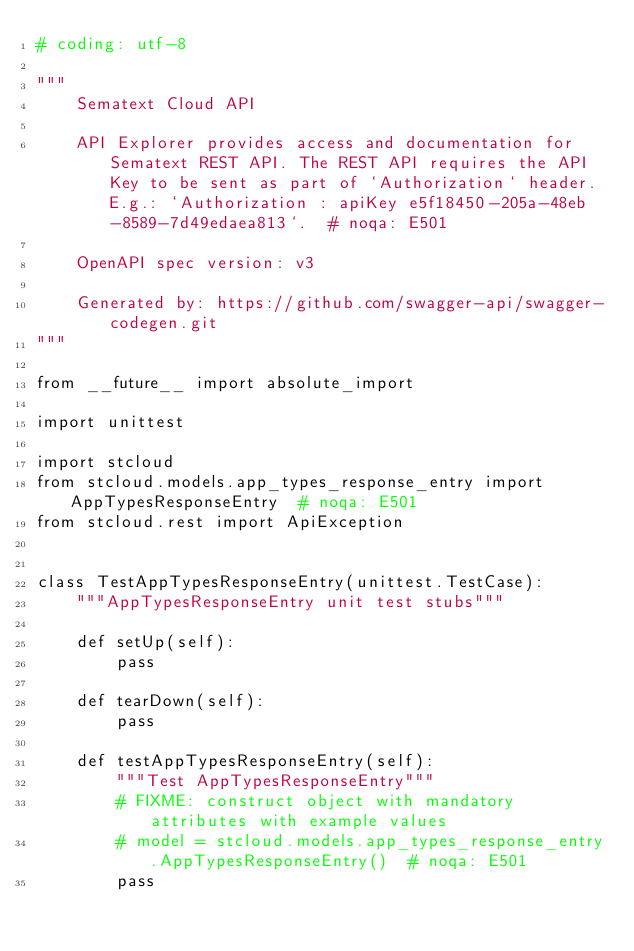<code> <loc_0><loc_0><loc_500><loc_500><_Python_># coding: utf-8

"""
    Sematext Cloud API

    API Explorer provides access and documentation for Sematext REST API. The REST API requires the API Key to be sent as part of `Authorization` header. E.g.: `Authorization : apiKey e5f18450-205a-48eb-8589-7d49edaea813`.  # noqa: E501

    OpenAPI spec version: v3
    
    Generated by: https://github.com/swagger-api/swagger-codegen.git
"""

from __future__ import absolute_import

import unittest

import stcloud
from stcloud.models.app_types_response_entry import AppTypesResponseEntry  # noqa: E501
from stcloud.rest import ApiException


class TestAppTypesResponseEntry(unittest.TestCase):
    """AppTypesResponseEntry unit test stubs"""

    def setUp(self):
        pass

    def tearDown(self):
        pass

    def testAppTypesResponseEntry(self):
        """Test AppTypesResponseEntry"""
        # FIXME: construct object with mandatory attributes with example values
        # model = stcloud.models.app_types_response_entry.AppTypesResponseEntry()  # noqa: E501
        pass

</code> 